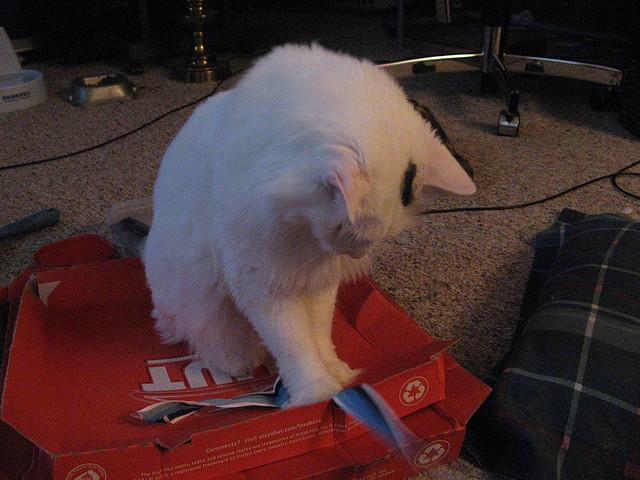What kind of animal is pictured?
Be succinct. Cat. Is this cat fixated on an object above him?
Write a very short answer. No. What kind of animals are these?
Short answer required. Cat. Can you recycle what the cat is sitting on?
Give a very brief answer. Yes. What is the cat looking at?
Keep it brief. Ribbon. What color is the cat?
Short answer required. White. Is there a log in the picture?
Write a very short answer. No. What kind of animal is this?
Keep it brief. Cat. What animal is in the photo?
Concise answer only. Cat. What is the cat sitting on?
Answer briefly. Pizza box. Is it possible that this cat has fleas?
Concise answer only. Yes. 